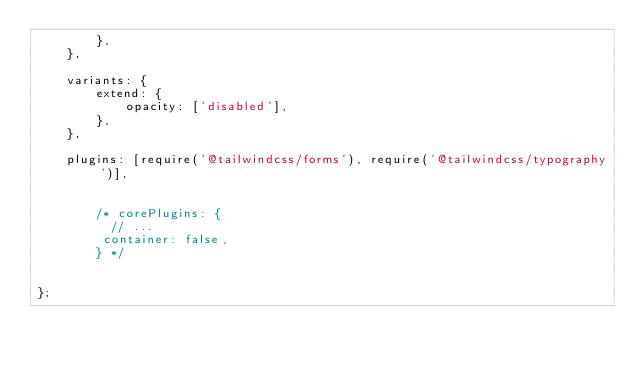<code> <loc_0><loc_0><loc_500><loc_500><_JavaScript_>        },
    },

    variants: {
        extend: {
            opacity: ['disabled'],
        },
    },

    plugins: [require('@tailwindcss/forms'), require('@tailwindcss/typography')],


        /* corePlugins: {
          // ...
         container: false,
        } */


};
</code> 